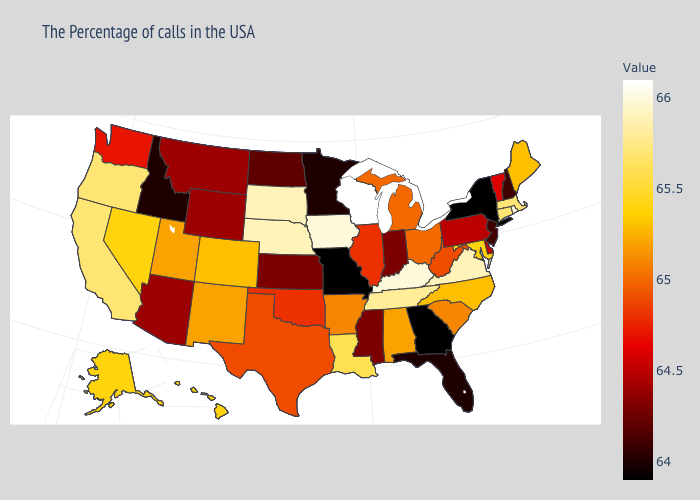Does Kansas have a lower value than Colorado?
Give a very brief answer. Yes. Does Wisconsin have the lowest value in the USA?
Keep it brief. No. Which states have the highest value in the USA?
Write a very short answer. Wisconsin. Which states have the lowest value in the USA?
Answer briefly. New York, Georgia, Missouri. Which states hav the highest value in the MidWest?
Quick response, please. Wisconsin. Does Georgia have the lowest value in the USA?
Write a very short answer. Yes. Which states have the lowest value in the Northeast?
Be succinct. New York. 